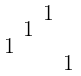Convert formula to latex. <formula><loc_0><loc_0><loc_500><loc_500>\begin{smallmatrix} & & 1 & \\ & 1 & & \\ 1 & & & \\ & & & 1 \end{smallmatrix}</formula> 